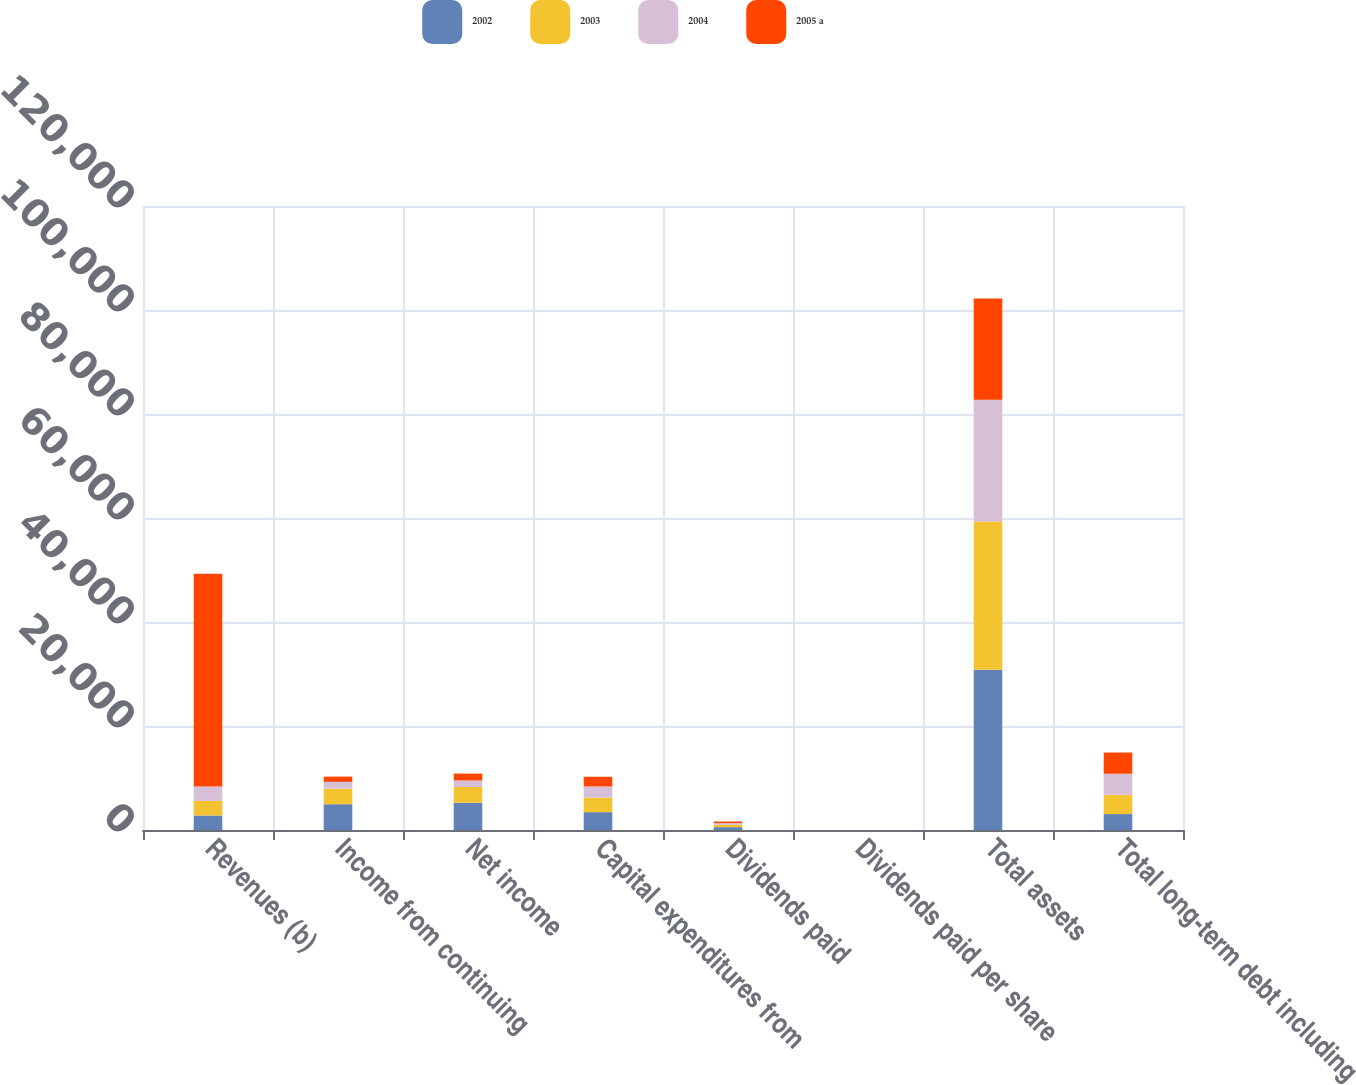Convert chart to OTSL. <chart><loc_0><loc_0><loc_500><loc_500><stacked_bar_chart><ecel><fcel>Revenues (b)<fcel>Income from continuing<fcel>Net income<fcel>Capital expenditures from<fcel>Dividends paid<fcel>Dividends paid per share<fcel>Total assets<fcel>Total long-term debt including<nl><fcel>2002<fcel>2796<fcel>4957<fcel>5234<fcel>3433<fcel>547<fcel>1.53<fcel>30831<fcel>3061<nl><fcel>2003<fcel>2796<fcel>3006<fcel>3032<fcel>2796<fcel>436<fcel>1.22<fcel>28498<fcel>3698<nl><fcel>2004<fcel>2796<fcel>1294<fcel>1261<fcel>2141<fcel>348<fcel>1.03<fcel>23423<fcel>4057<nl><fcel>2005 a<fcel>40907<fcel>1010<fcel>1321<fcel>1873<fcel>298<fcel>0.96<fcel>19482<fcel>4085<nl></chart> 